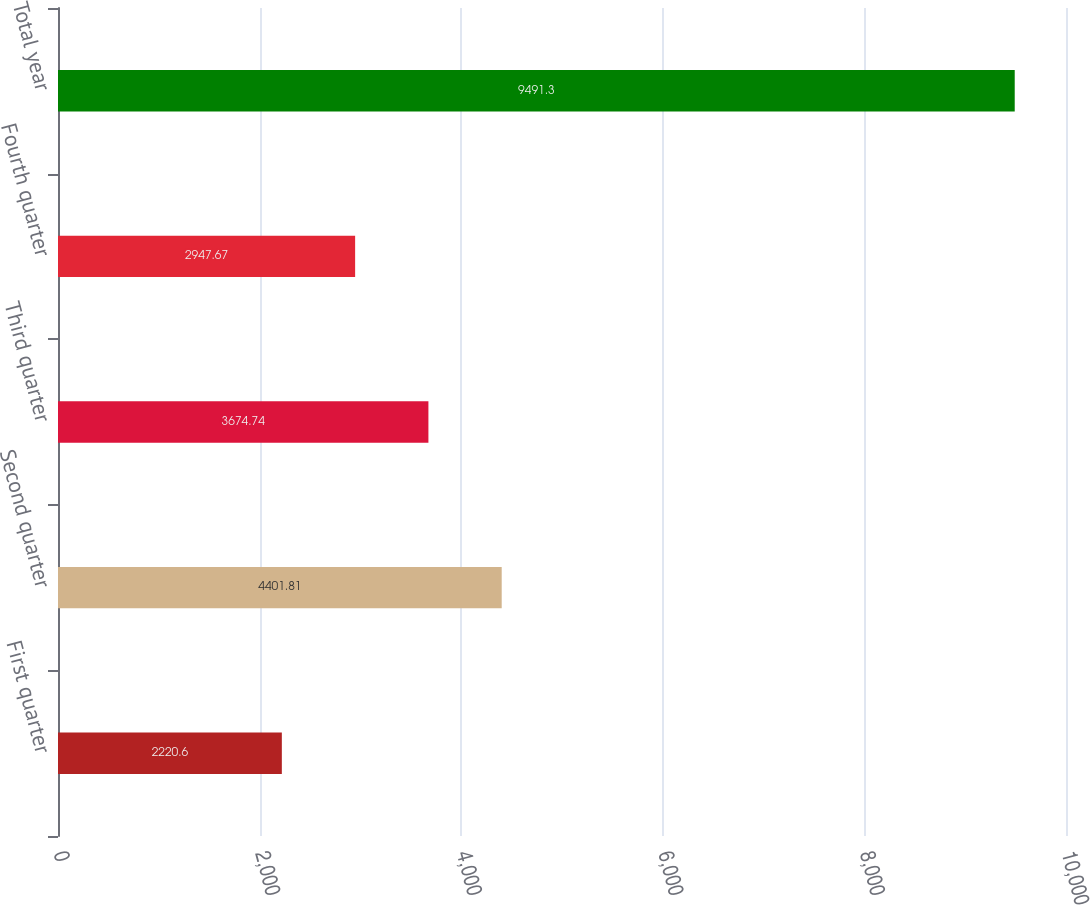Convert chart to OTSL. <chart><loc_0><loc_0><loc_500><loc_500><bar_chart><fcel>First quarter<fcel>Second quarter<fcel>Third quarter<fcel>Fourth quarter<fcel>Total year<nl><fcel>2220.6<fcel>4401.81<fcel>3674.74<fcel>2947.67<fcel>9491.3<nl></chart> 